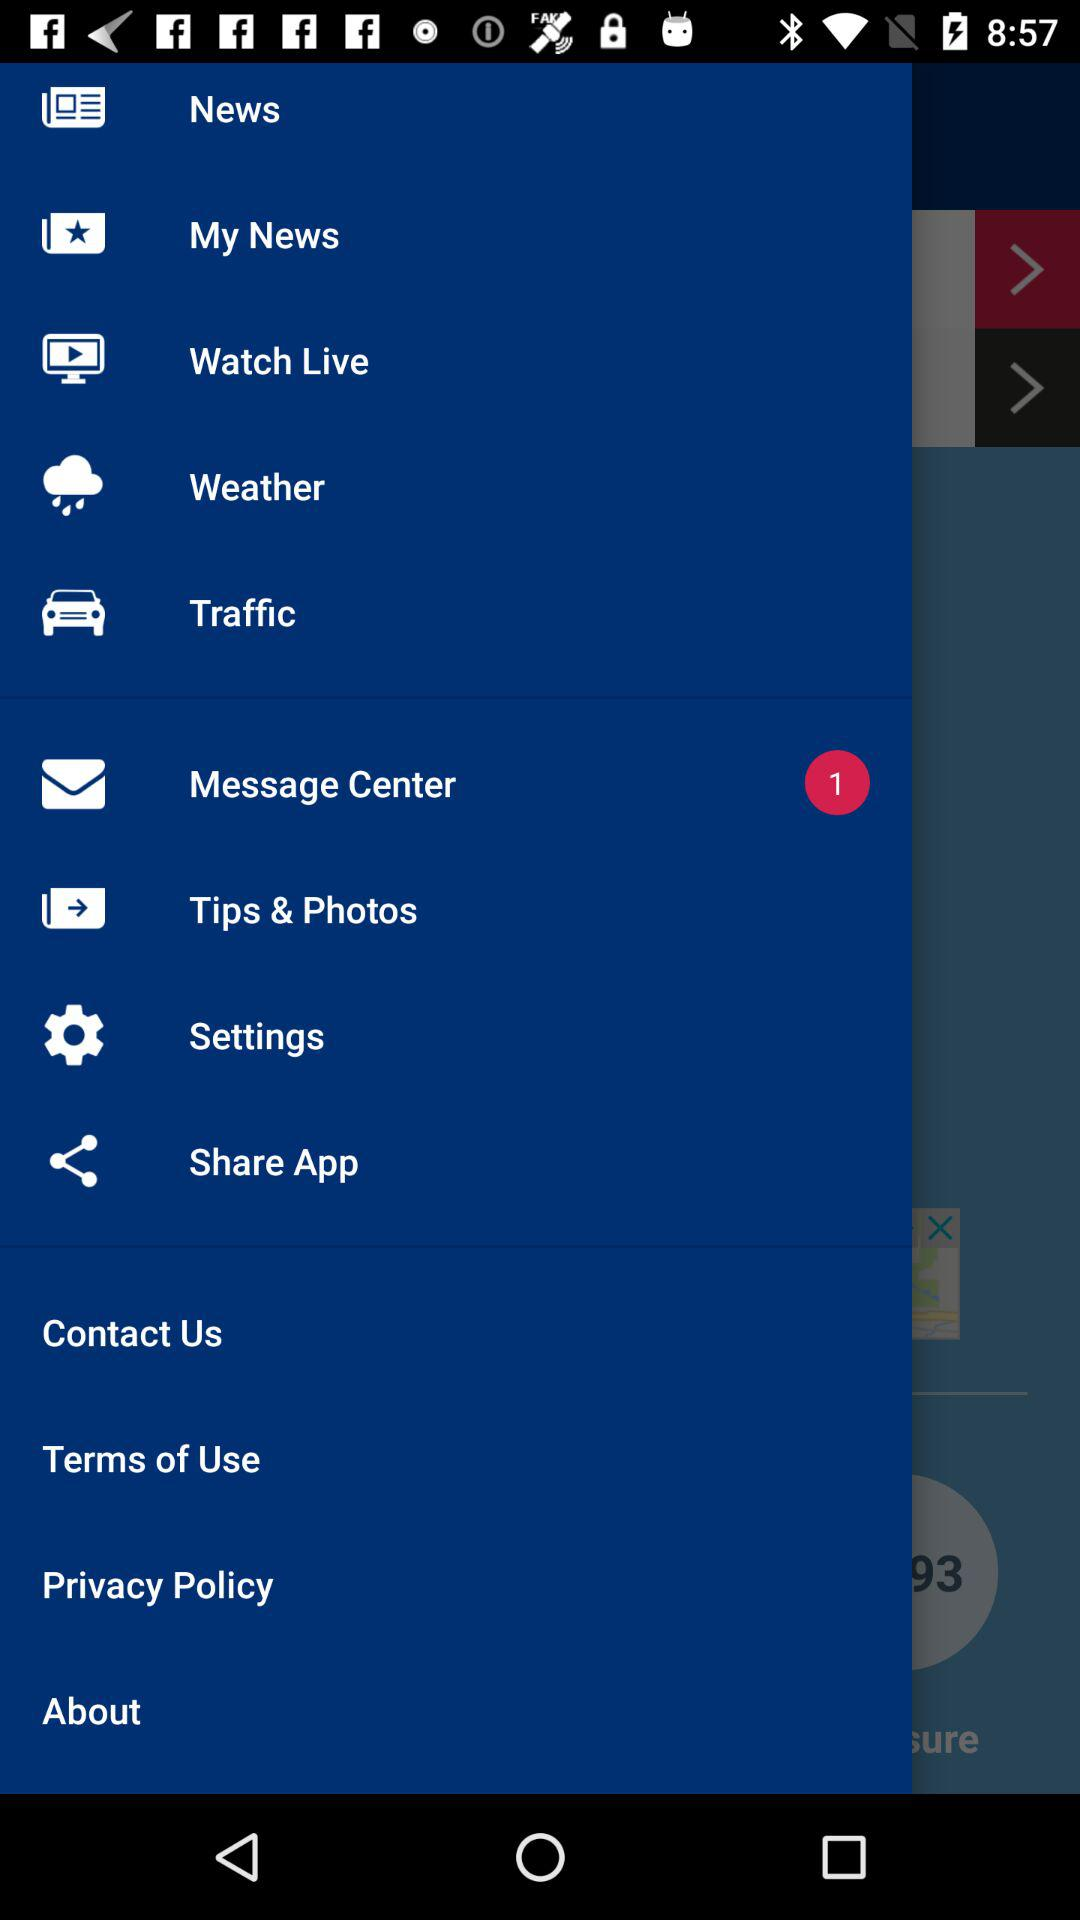How many items have a red circle with a number in it?
Answer the question using a single word or phrase. 1 